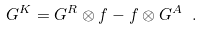Convert formula to latex. <formula><loc_0><loc_0><loc_500><loc_500>G ^ { K } = G ^ { R } \otimes f - f \otimes G ^ { A } \ .</formula> 